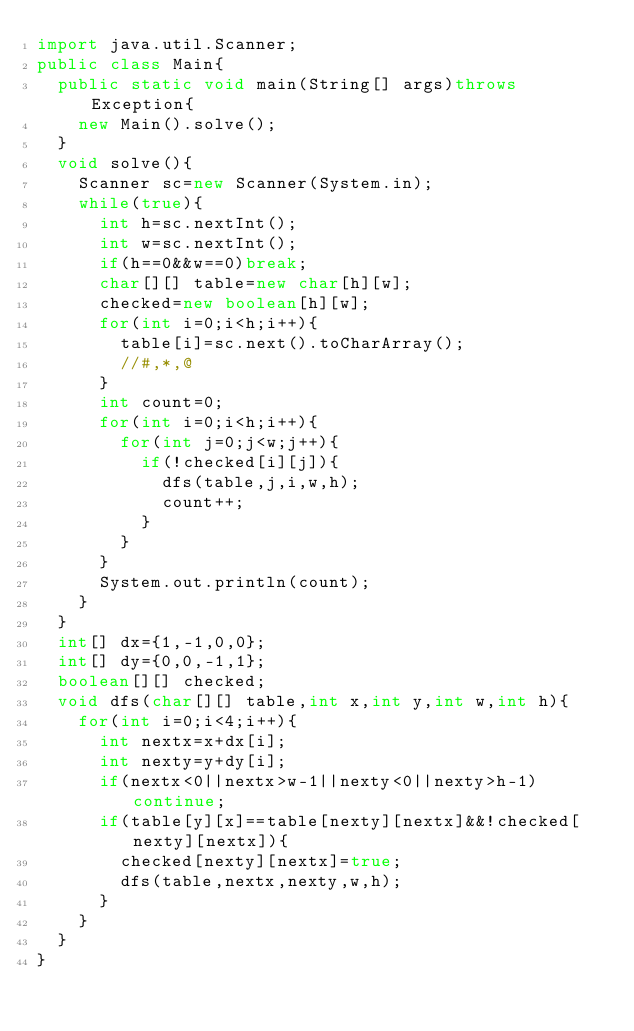<code> <loc_0><loc_0><loc_500><loc_500><_Java_>import java.util.Scanner;
public class Main{
	public static void main(String[] args)throws Exception{
		new Main().solve();
	}
	void solve(){
		Scanner sc=new Scanner(System.in);
		while(true){
			int h=sc.nextInt();
			int w=sc.nextInt();
			if(h==0&&w==0)break;
			char[][] table=new char[h][w];
			checked=new boolean[h][w];
			for(int i=0;i<h;i++){
				table[i]=sc.next().toCharArray();
				//#,*,@
			}
			int count=0;
			for(int i=0;i<h;i++){
				for(int j=0;j<w;j++){
					if(!checked[i][j]){
						dfs(table,j,i,w,h);
						count++;
					}
				}
			}
			System.out.println(count);
		}
	}
	int[] dx={1,-1,0,0};
	int[] dy={0,0,-1,1};
	boolean[][] checked;
	void dfs(char[][] table,int x,int y,int w,int h){
		for(int i=0;i<4;i++){
			int nextx=x+dx[i];
			int nexty=y+dy[i];
			if(nextx<0||nextx>w-1||nexty<0||nexty>h-1)continue;
			if(table[y][x]==table[nexty][nextx]&&!checked[nexty][nextx]){
				checked[nexty][nextx]=true;
				dfs(table,nextx,nexty,w,h);
			}
		}
	}
}</code> 